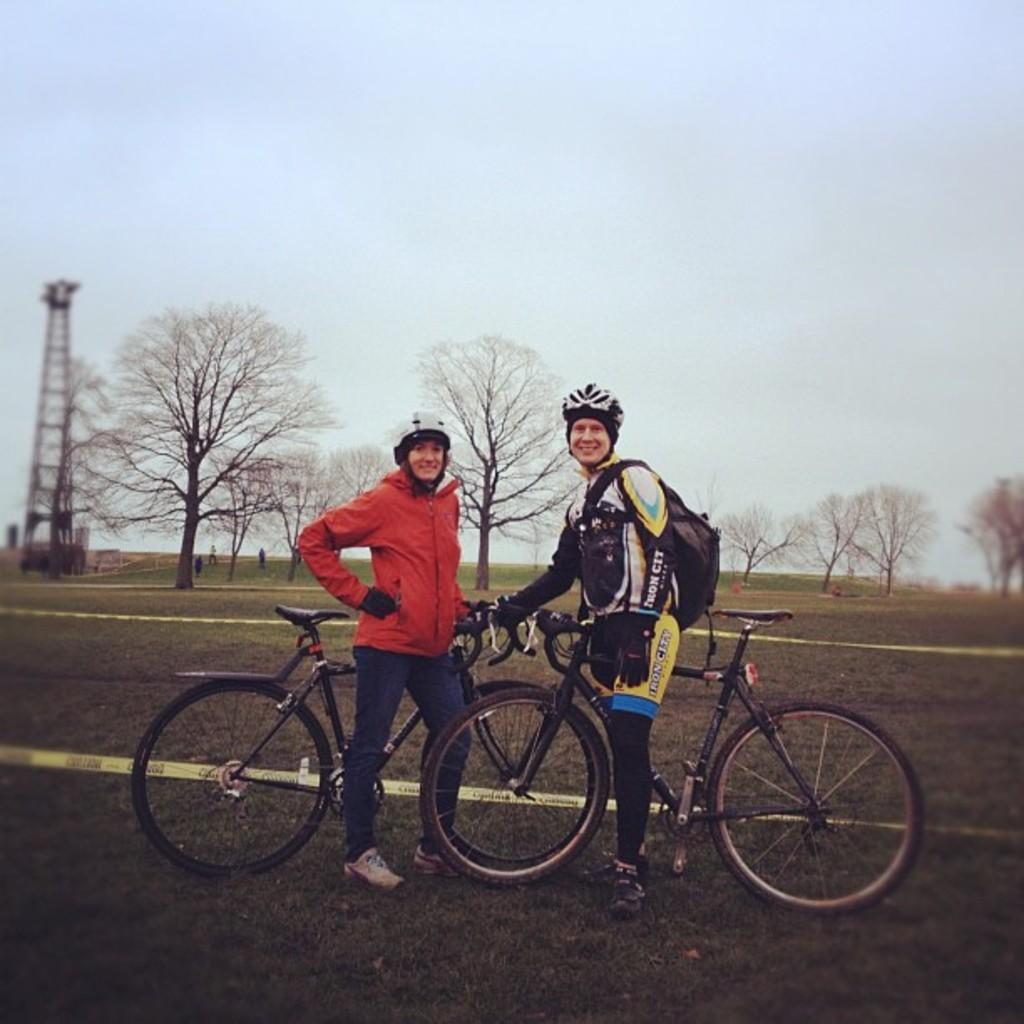Could you give a brief overview of what you see in this image? In the image there are two persons beside bicycle on a grass field and on left side there is a tower. 